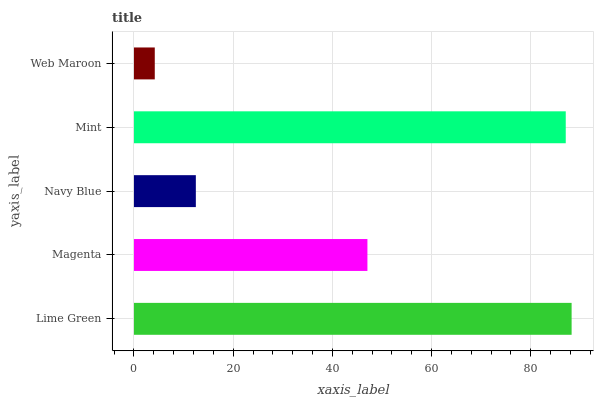Is Web Maroon the minimum?
Answer yes or no. Yes. Is Lime Green the maximum?
Answer yes or no. Yes. Is Magenta the minimum?
Answer yes or no. No. Is Magenta the maximum?
Answer yes or no. No. Is Lime Green greater than Magenta?
Answer yes or no. Yes. Is Magenta less than Lime Green?
Answer yes or no. Yes. Is Magenta greater than Lime Green?
Answer yes or no. No. Is Lime Green less than Magenta?
Answer yes or no. No. Is Magenta the high median?
Answer yes or no. Yes. Is Magenta the low median?
Answer yes or no. Yes. Is Lime Green the high median?
Answer yes or no. No. Is Web Maroon the low median?
Answer yes or no. No. 